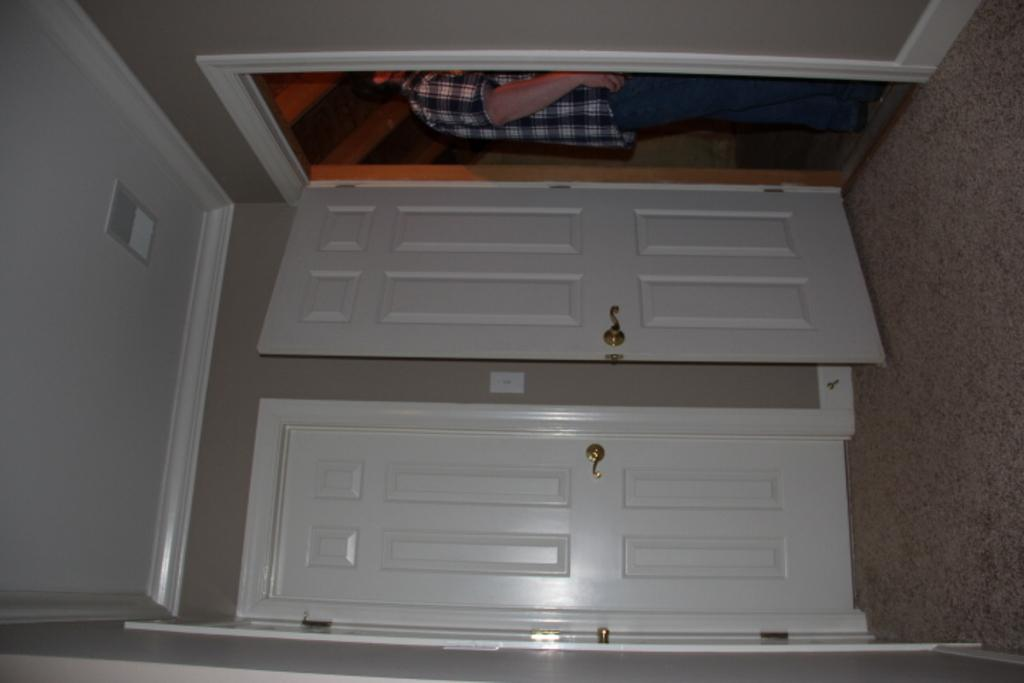What is located in the center of the image? There are doors in the center of the image. What is the color of the doors? The doors are white in color. Can you describe the person in the image? There is a person at the top of the image. What is on the left side of the image? There is a wall on the left side of the image. What is the color of the wall? The wall is white in color. How many spiders are crawling on the wall in the image? There are no spiders present in the image; the wall is white in color. What type of finger can be seen holding the door handle in the image? There is no finger visible in the image; only a person is present at the top of the image. 